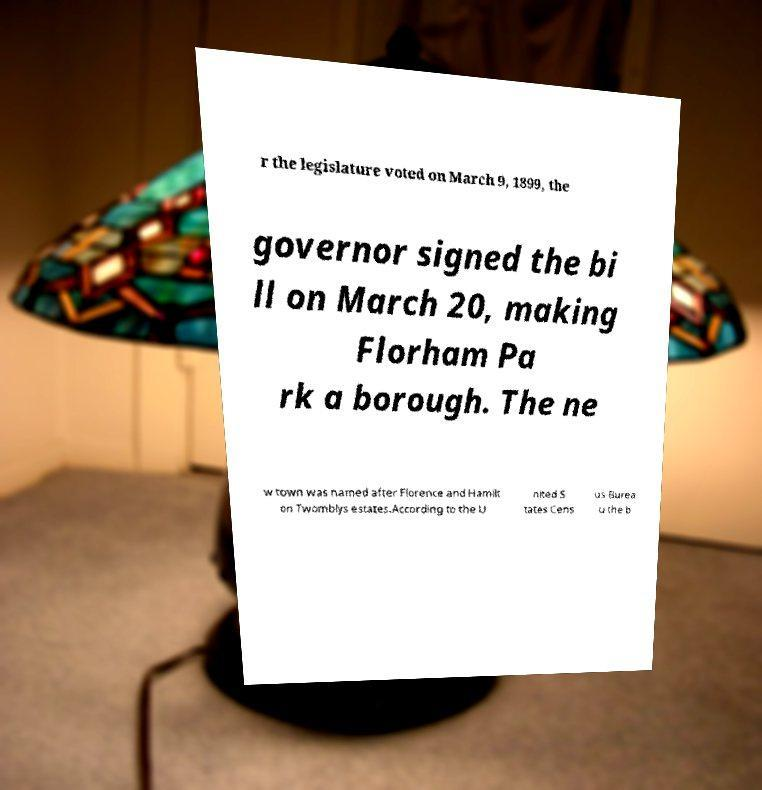What messages or text are displayed in this image? I need them in a readable, typed format. r the legislature voted on March 9, 1899, the governor signed the bi ll on March 20, making Florham Pa rk a borough. The ne w town was named after Florence and Hamilt on Twomblys estates.According to the U nited S tates Cens us Burea u the b 